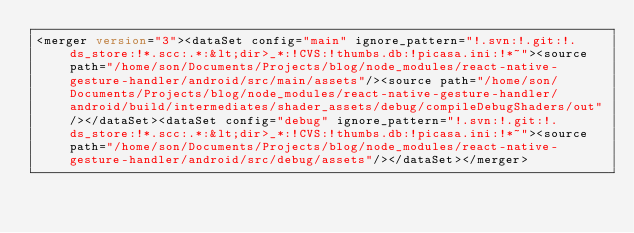<code> <loc_0><loc_0><loc_500><loc_500><_XML_><merger version="3"><dataSet config="main" ignore_pattern="!.svn:!.git:!.ds_store:!*.scc:.*:&lt;dir>_*:!CVS:!thumbs.db:!picasa.ini:!*~"><source path="/home/son/Documents/Projects/blog/node_modules/react-native-gesture-handler/android/src/main/assets"/><source path="/home/son/Documents/Projects/blog/node_modules/react-native-gesture-handler/android/build/intermediates/shader_assets/debug/compileDebugShaders/out"/></dataSet><dataSet config="debug" ignore_pattern="!.svn:!.git:!.ds_store:!*.scc:.*:&lt;dir>_*:!CVS:!thumbs.db:!picasa.ini:!*~"><source path="/home/son/Documents/Projects/blog/node_modules/react-native-gesture-handler/android/src/debug/assets"/></dataSet></merger></code> 